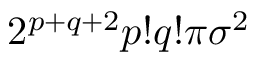<formula> <loc_0><loc_0><loc_500><loc_500>2 ^ { p + q + 2 } p ! q ! \pi \sigma ^ { 2 }</formula> 